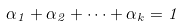<formula> <loc_0><loc_0><loc_500><loc_500>\alpha _ { 1 } + \alpha _ { 2 } + \dots + \alpha _ { k } = 1</formula> 